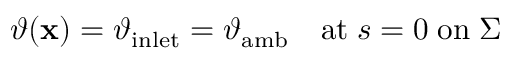Convert formula to latex. <formula><loc_0><loc_0><loc_500><loc_500>\begin{array} { r } { \vartheta ( x ) = \vartheta _ { i n l e t } = \vartheta _ { a m b } \quad a t \, s = 0 \, o n \, \Sigma } \end{array}</formula> 